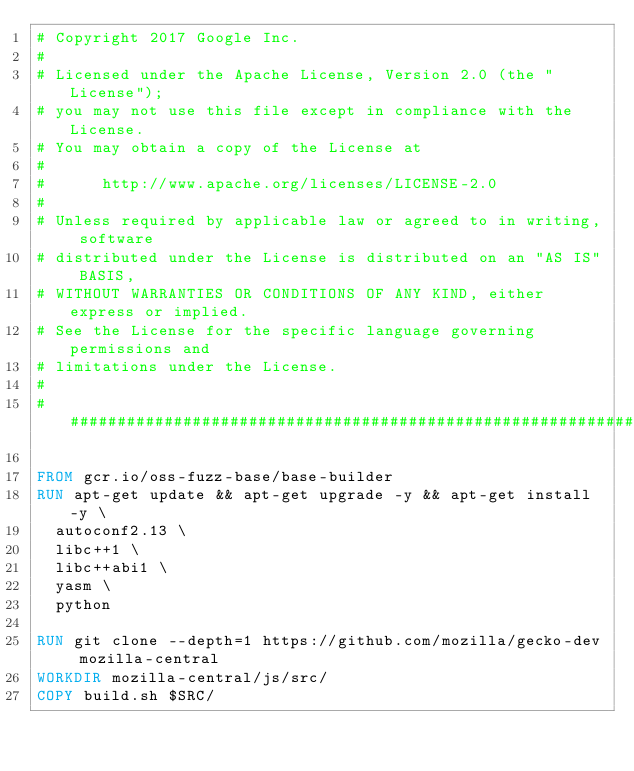<code> <loc_0><loc_0><loc_500><loc_500><_Dockerfile_># Copyright 2017 Google Inc.
#
# Licensed under the Apache License, Version 2.0 (the "License");
# you may not use this file except in compliance with the License.
# You may obtain a copy of the License at
#
#      http://www.apache.org/licenses/LICENSE-2.0
#
# Unless required by applicable law or agreed to in writing, software
# distributed under the License is distributed on an "AS IS" BASIS,
# WITHOUT WARRANTIES OR CONDITIONS OF ANY KIND, either express or implied.
# See the License for the specific language governing permissions and
# limitations under the License.
#
################################################################################

FROM gcr.io/oss-fuzz-base/base-builder
RUN apt-get update && apt-get upgrade -y && apt-get install -y \
  autoconf2.13 \
  libc++1 \
  libc++abi1 \
  yasm \
  python

RUN git clone --depth=1 https://github.com/mozilla/gecko-dev mozilla-central
WORKDIR mozilla-central/js/src/
COPY build.sh $SRC/
</code> 